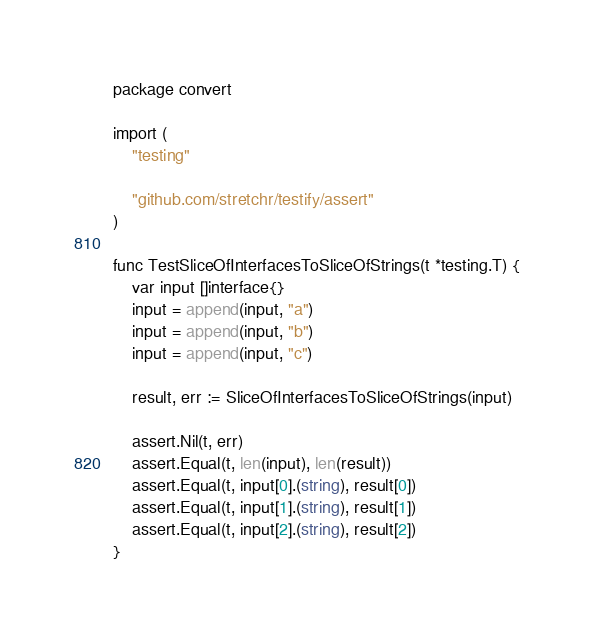<code> <loc_0><loc_0><loc_500><loc_500><_Go_>package convert

import (
	"testing"

	"github.com/stretchr/testify/assert"
)

func TestSliceOfInterfacesToSliceOfStrings(t *testing.T) {
	var input []interface{}
	input = append(input, "a")
	input = append(input, "b")
	input = append(input, "c")

	result, err := SliceOfInterfacesToSliceOfStrings(input)

	assert.Nil(t, err)
	assert.Equal(t, len(input), len(result))
	assert.Equal(t, input[0].(string), result[0])
	assert.Equal(t, input[1].(string), result[1])
	assert.Equal(t, input[2].(string), result[2])
}
</code> 